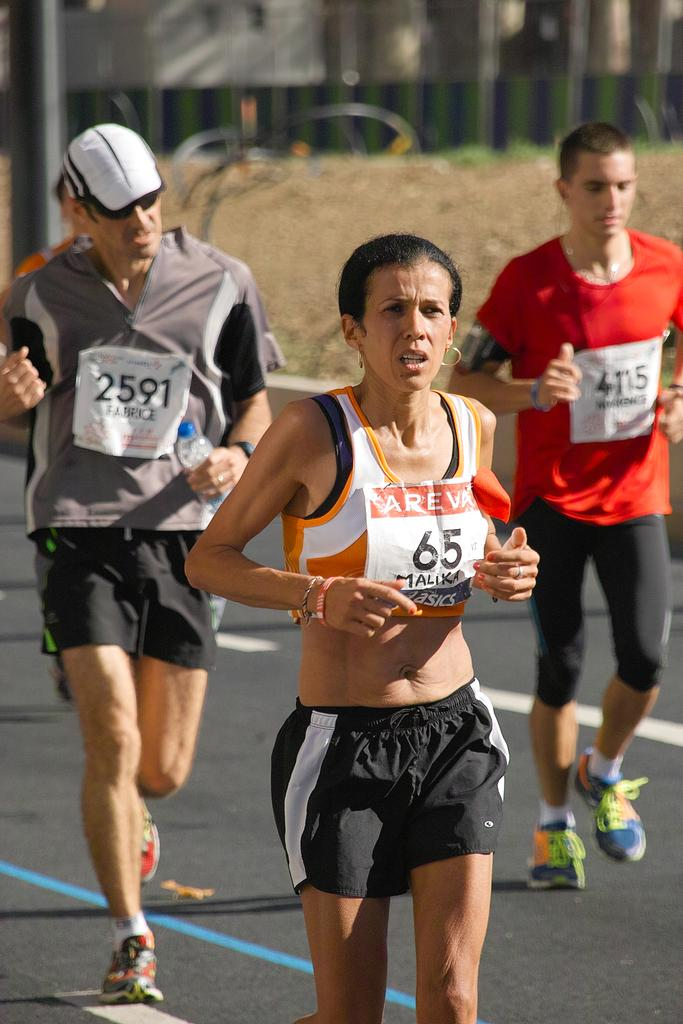Provide a one-sentence caption for the provided image. A female running with the number 65 and two runners behind her. 